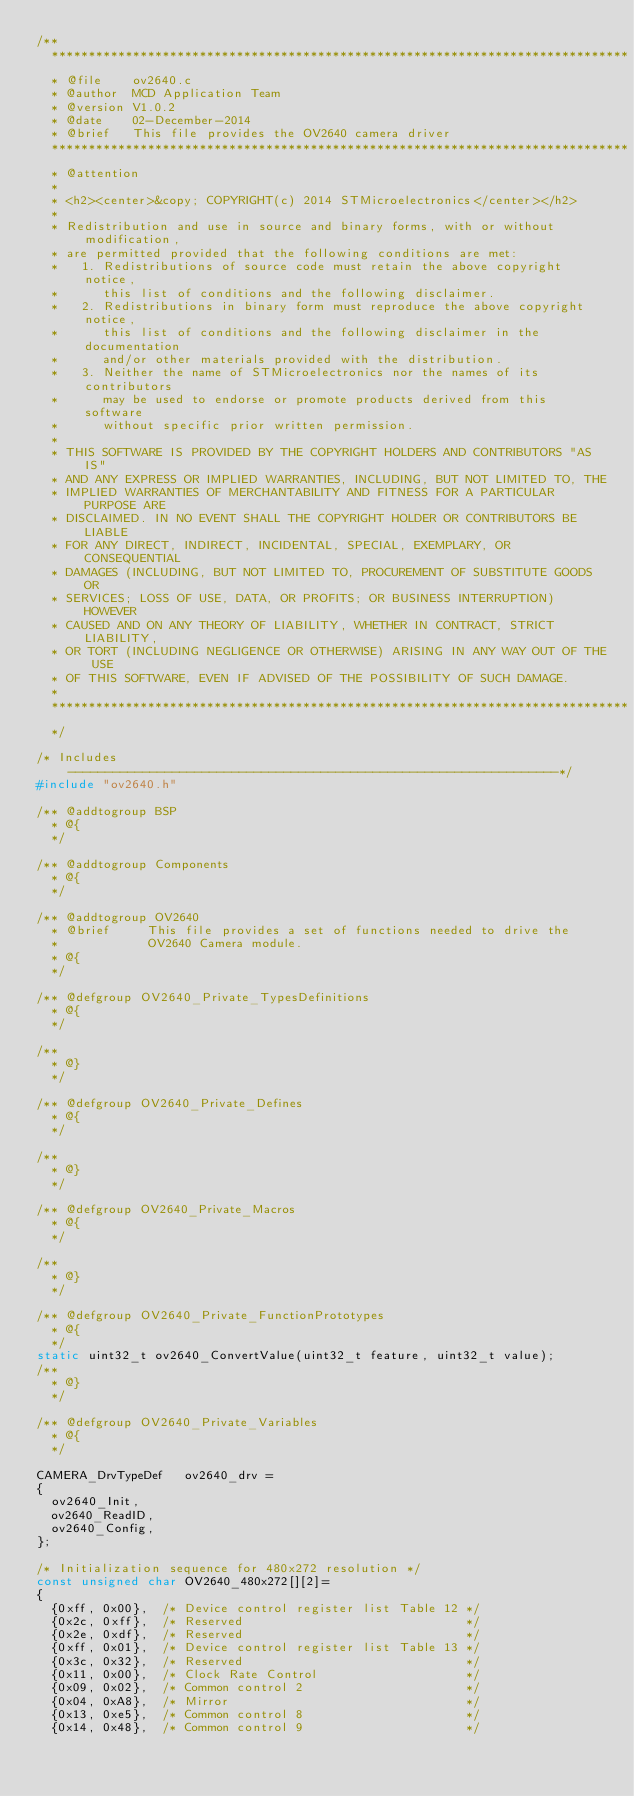<code> <loc_0><loc_0><loc_500><loc_500><_C_>/**
  ******************************************************************************
  * @file    ov2640.c
  * @author  MCD Application Team
  * @version V1.0.2
  * @date    02-December-2014
  * @brief   This file provides the OV2640 camera driver
  ******************************************************************************
  * @attention
  *
  * <h2><center>&copy; COPYRIGHT(c) 2014 STMicroelectronics</center></h2>
  *
  * Redistribution and use in source and binary forms, with or without modification,
  * are permitted provided that the following conditions are met:
  *   1. Redistributions of source code must retain the above copyright notice,
  *      this list of conditions and the following disclaimer.
  *   2. Redistributions in binary form must reproduce the above copyright notice,
  *      this list of conditions and the following disclaimer in the documentation
  *      and/or other materials provided with the distribution.
  *   3. Neither the name of STMicroelectronics nor the names of its contributors
  *      may be used to endorse or promote products derived from this software
  *      without specific prior written permission.
  *
  * THIS SOFTWARE IS PROVIDED BY THE COPYRIGHT HOLDERS AND CONTRIBUTORS "AS IS"
  * AND ANY EXPRESS OR IMPLIED WARRANTIES, INCLUDING, BUT NOT LIMITED TO, THE
  * IMPLIED WARRANTIES OF MERCHANTABILITY AND FITNESS FOR A PARTICULAR PURPOSE ARE
  * DISCLAIMED. IN NO EVENT SHALL THE COPYRIGHT HOLDER OR CONTRIBUTORS BE LIABLE
  * FOR ANY DIRECT, INDIRECT, INCIDENTAL, SPECIAL, EXEMPLARY, OR CONSEQUENTIAL
  * DAMAGES (INCLUDING, BUT NOT LIMITED TO, PROCUREMENT OF SUBSTITUTE GOODS OR
  * SERVICES; LOSS OF USE, DATA, OR PROFITS; OR BUSINESS INTERRUPTION) HOWEVER
  * CAUSED AND ON ANY THEORY OF LIABILITY, WHETHER IN CONTRACT, STRICT LIABILITY,
  * OR TORT (INCLUDING NEGLIGENCE OR OTHERWISE) ARISING IN ANY WAY OUT OF THE USE
  * OF THIS SOFTWARE, EVEN IF ADVISED OF THE POSSIBILITY OF SUCH DAMAGE.
  *
  ******************************************************************************
  */ 

/* Includes ------------------------------------------------------------------*/
#include "ov2640.h"

/** @addtogroup BSP
  * @{
  */ 

/** @addtogroup Components
  * @{
  */ 
  
/** @addtogroup OV2640
  * @brief     This file provides a set of functions needed to drive the 
  *            OV2640 Camera module.
  * @{
  */

/** @defgroup OV2640_Private_TypesDefinitions
  * @{
  */ 

/**
  * @}
  */ 

/** @defgroup OV2640_Private_Defines
  * @{
  */

/**
  * @}
  */ 
  
/** @defgroup OV2640_Private_Macros
  * @{
  */
     
/**
  * @}
  */  
  
/** @defgroup OV2640_Private_FunctionPrototypes
  * @{
  */
static uint32_t ov2640_ConvertValue(uint32_t feature, uint32_t value);
/**
  * @}
  */ 
  
/** @defgroup OV2640_Private_Variables
  * @{
  */        

CAMERA_DrvTypeDef   ov2640_drv = 
{
  ov2640_Init,
  ov2640_ReadID,  
  ov2640_Config,
};

/* Initialization sequence for 480x272 resolution */
const unsigned char OV2640_480x272[][2]=
{
  {0xff, 0x00},  /* Device control register list Table 12 */
  {0x2c, 0xff},  /* Reserved                              */
  {0x2e, 0xdf},  /* Reserved                              */
  {0xff, 0x01},  /* Device control register list Table 13 */
  {0x3c, 0x32},  /* Reserved                              */
  {0x11, 0x00},  /* Clock Rate Control                    */
  {0x09, 0x02},  /* Common control 2                      */
  {0x04, 0xA8},  /* Mirror                                */
  {0x13, 0xe5},  /* Common control 8                      */
  {0x14, 0x48},  /* Common control 9                      */</code> 